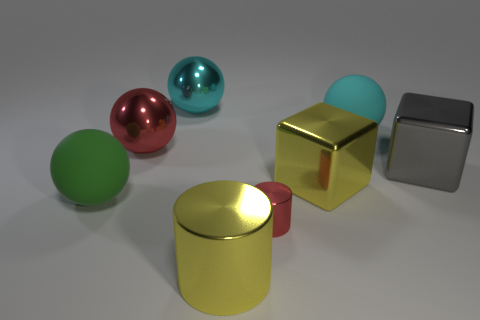Subtract all purple spheres. Subtract all red cylinders. How many spheres are left? 4 Add 2 large rubber cubes. How many objects exist? 10 Subtract all cylinders. How many objects are left? 6 Add 2 large gray things. How many large gray things are left? 3 Add 1 tiny objects. How many tiny objects exist? 2 Subtract 0 purple blocks. How many objects are left? 8 Subtract all tiny yellow balls. Subtract all large cyan rubber objects. How many objects are left? 7 